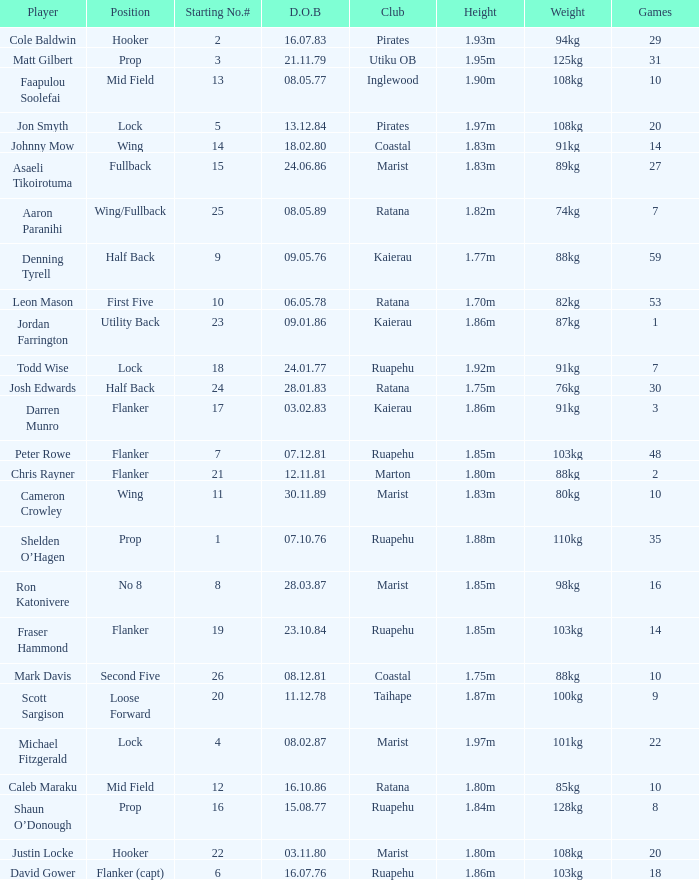What position does the player Todd Wise play in? Lock. 